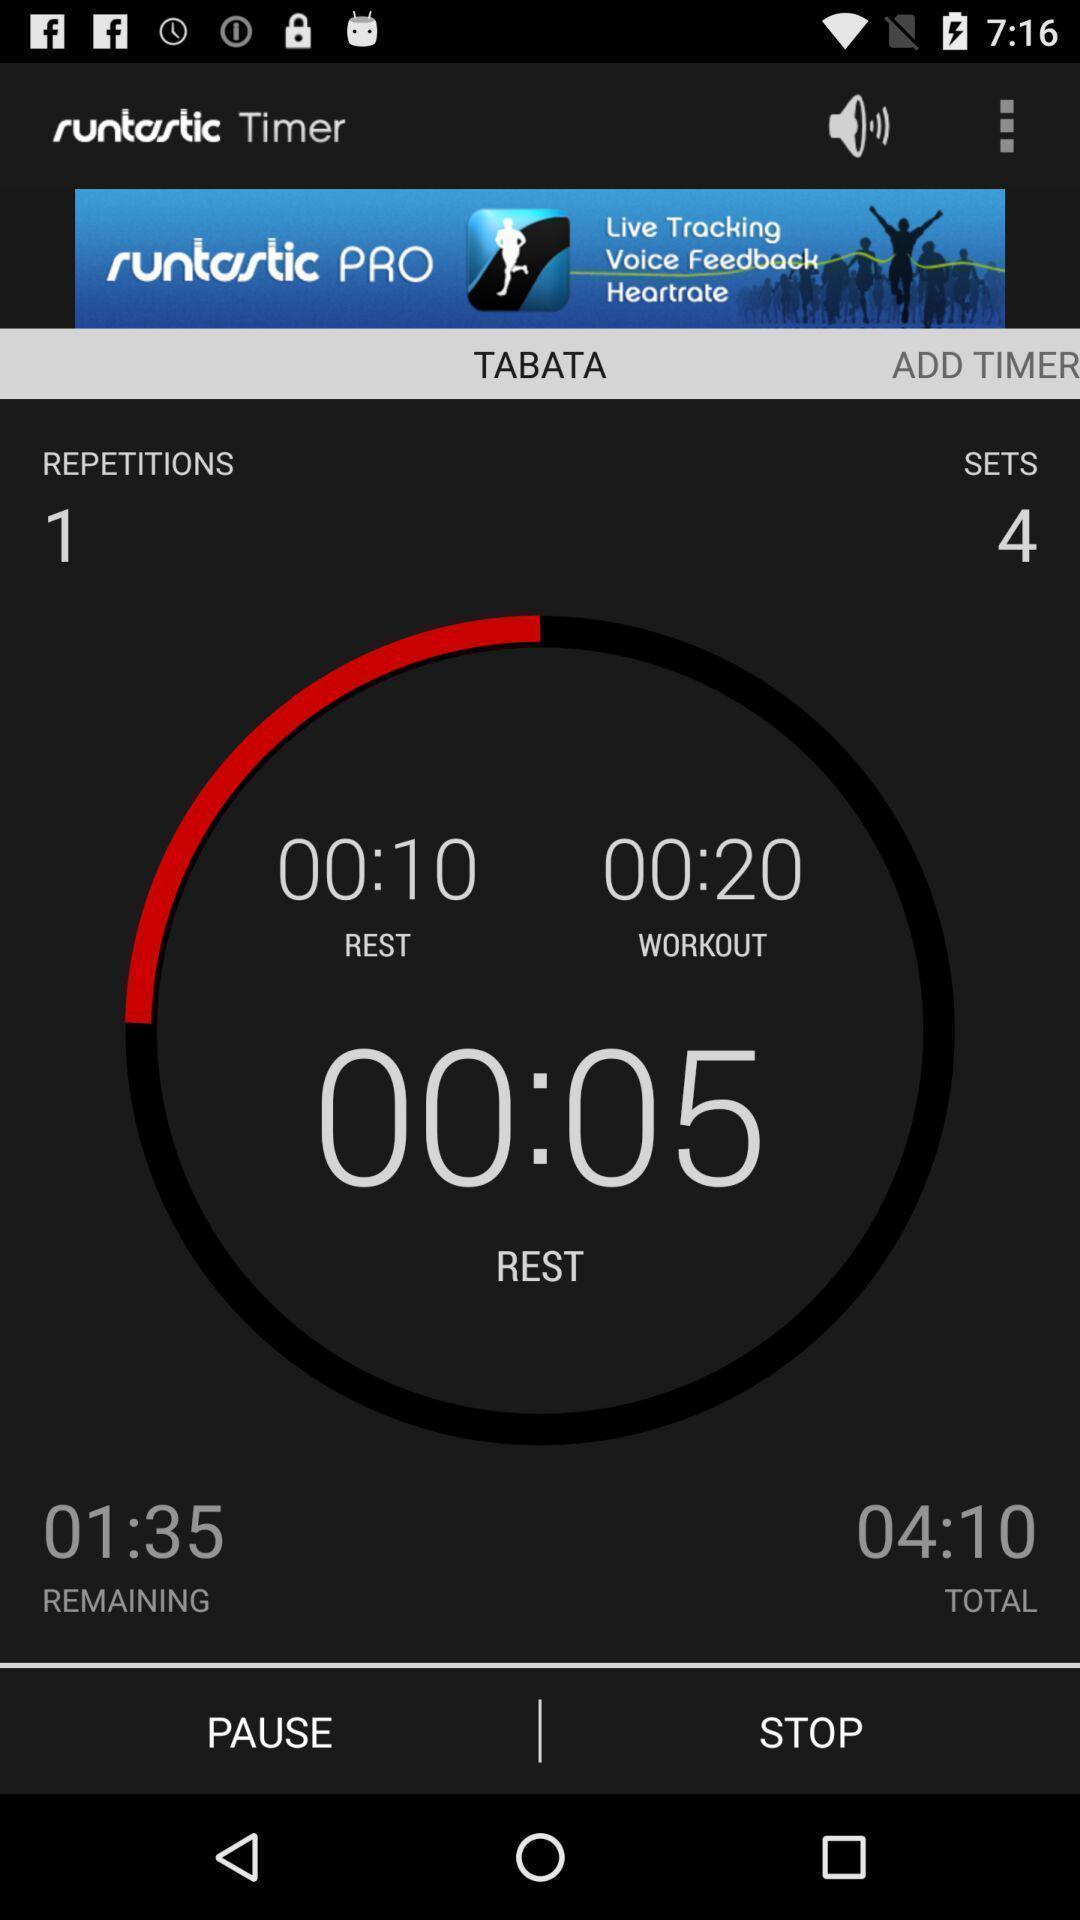Explain what's happening in this screen capture. Running time in a fitness app. 